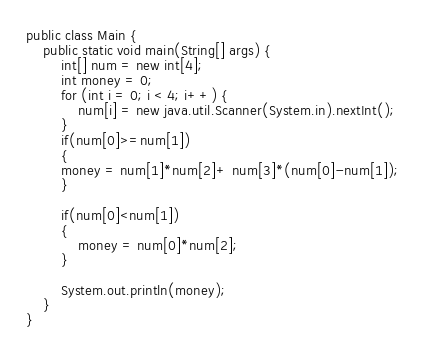Convert code to text. <code><loc_0><loc_0><loc_500><loc_500><_Java_>
public class Main {
	public static void main(String[] args) {
		int[] num = new int[4];
		int money = 0;
		for (int i = 0; i < 4; i++) {
			num[i] = new java.util.Scanner(System.in).nextInt();
		}
		if(num[0]>=num[1])
		{
		money = num[1]*num[2]+ num[3]*(num[0]-num[1]);
		}

		if(num[0]<num[1])
		{
			money = num[0]*num[2];
		}

		System.out.println(money);
	}
}
</code> 